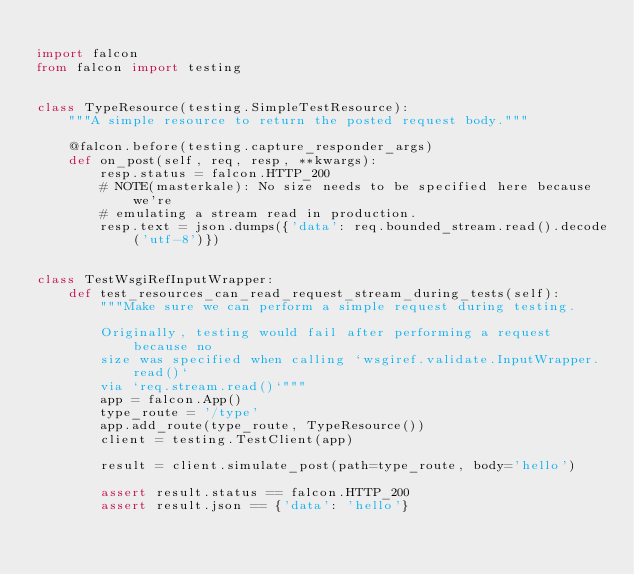Convert code to text. <code><loc_0><loc_0><loc_500><loc_500><_Python_>
import falcon
from falcon import testing


class TypeResource(testing.SimpleTestResource):
    """A simple resource to return the posted request body."""

    @falcon.before(testing.capture_responder_args)
    def on_post(self, req, resp, **kwargs):
        resp.status = falcon.HTTP_200
        # NOTE(masterkale): No size needs to be specified here because we're
        # emulating a stream read in production.
        resp.text = json.dumps({'data': req.bounded_stream.read().decode('utf-8')})


class TestWsgiRefInputWrapper:
    def test_resources_can_read_request_stream_during_tests(self):
        """Make sure we can perform a simple request during testing.

        Originally, testing would fail after performing a request because no
        size was specified when calling `wsgiref.validate.InputWrapper.read()`
        via `req.stream.read()`"""
        app = falcon.App()
        type_route = '/type'
        app.add_route(type_route, TypeResource())
        client = testing.TestClient(app)

        result = client.simulate_post(path=type_route, body='hello')

        assert result.status == falcon.HTTP_200
        assert result.json == {'data': 'hello'}
</code> 